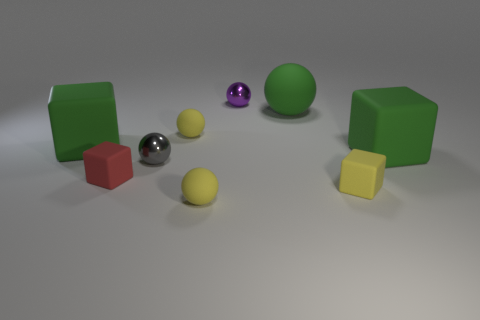Subtract all small shiny spheres. How many spheres are left? 3 Subtract all gray spheres. How many spheres are left? 4 Subtract all brown cubes. Subtract all cyan spheres. How many cubes are left? 4 Add 1 purple metal objects. How many objects exist? 10 Subtract all cubes. How many objects are left? 5 Subtract 0 gray cylinders. How many objects are left? 9 Subtract all yellow cubes. Subtract all small shiny things. How many objects are left? 6 Add 1 tiny cubes. How many tiny cubes are left? 3 Add 1 balls. How many balls exist? 6 